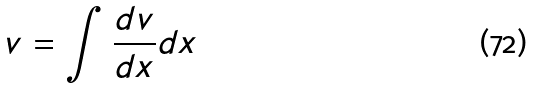<formula> <loc_0><loc_0><loc_500><loc_500>v = \int \frac { d v } { d x } d x</formula> 